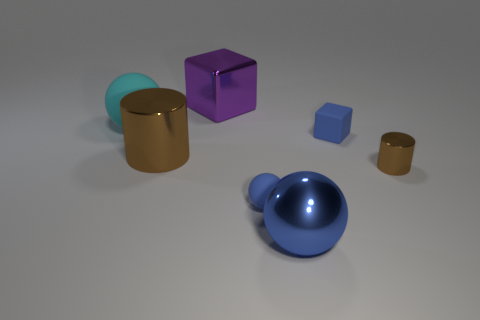Add 3 cyan spheres. How many objects exist? 10 Subtract all blocks. How many objects are left? 5 Add 6 small gray rubber objects. How many small gray rubber objects exist? 6 Subtract 0 green cylinders. How many objects are left? 7 Subtract all small cyan objects. Subtract all big cyan matte things. How many objects are left? 6 Add 7 rubber blocks. How many rubber blocks are left? 8 